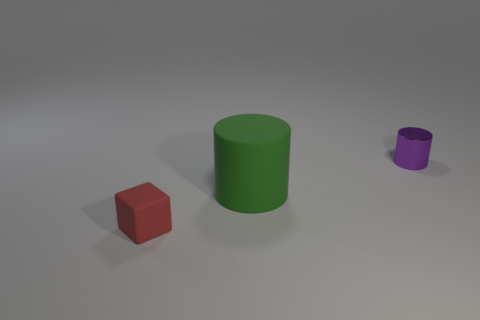Do the large matte thing and the tiny purple shiny thing have the same shape? yes 